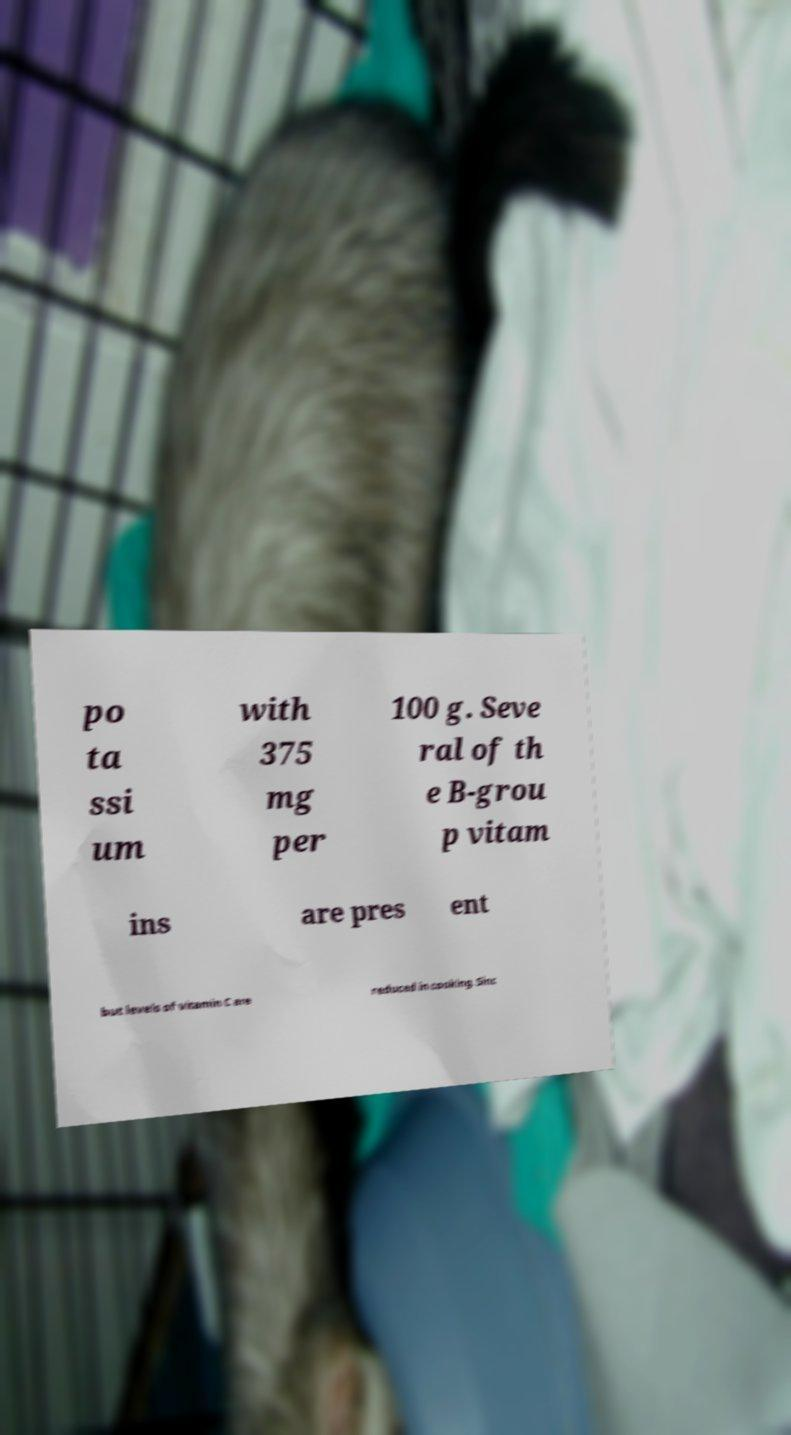What messages or text are displayed in this image? I need them in a readable, typed format. po ta ssi um with 375 mg per 100 g. Seve ral of th e B-grou p vitam ins are pres ent but levels of vitamin C are reduced in cooking. Sinc 